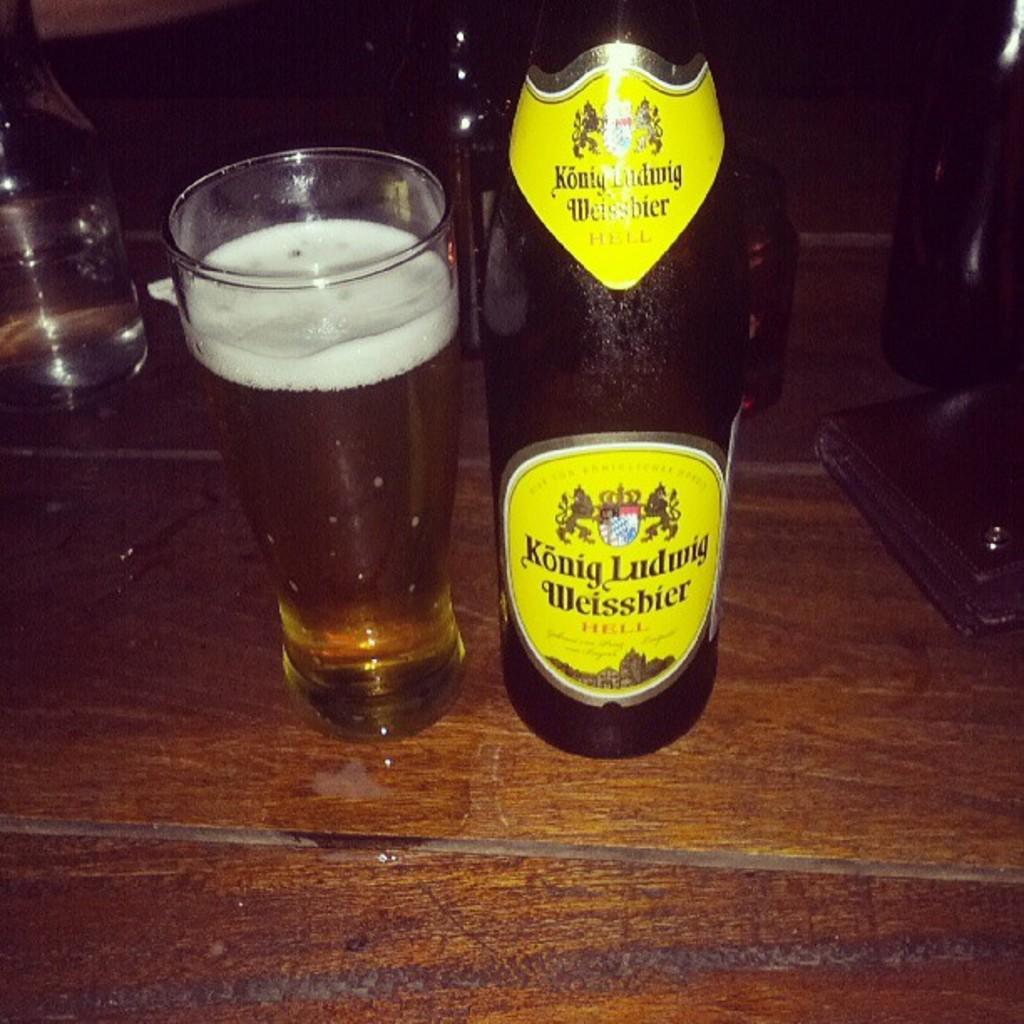What is the name of the beer?
Your answer should be very brief. Konig ludwig weissbier. 